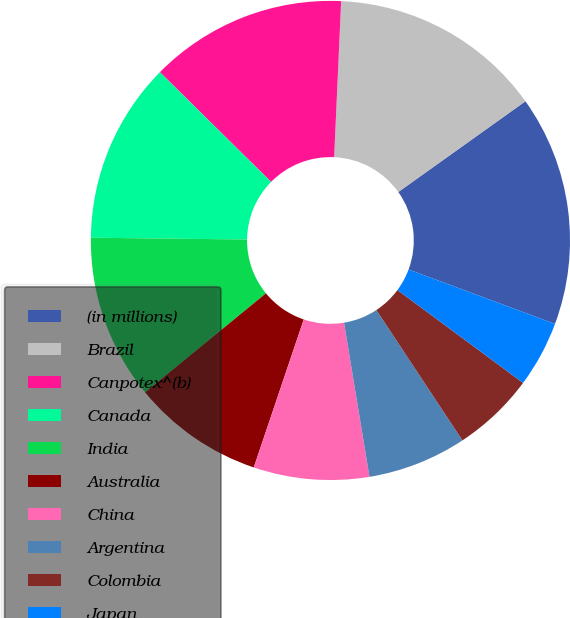<chart> <loc_0><loc_0><loc_500><loc_500><pie_chart><fcel>(in millions)<fcel>Brazil<fcel>Canpotex^(b)<fcel>Canada<fcel>India<fcel>Australia<fcel>China<fcel>Argentina<fcel>Colombia<fcel>Japan<nl><fcel>15.53%<fcel>14.42%<fcel>13.32%<fcel>12.21%<fcel>11.11%<fcel>8.89%<fcel>7.79%<fcel>6.68%<fcel>5.58%<fcel>4.47%<nl></chart> 